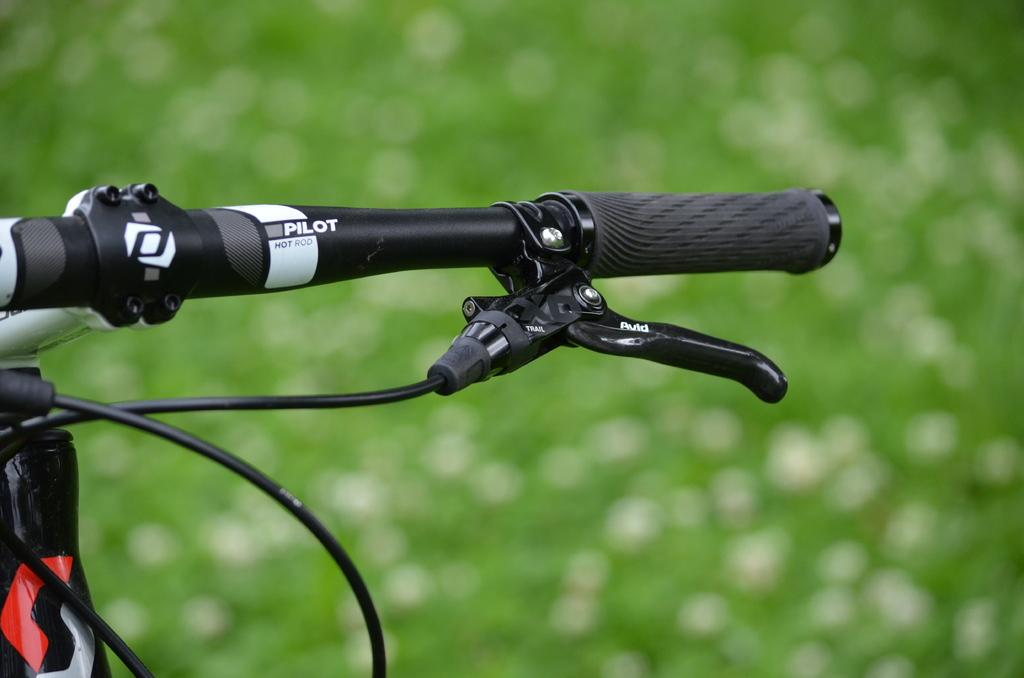What part of a cycle can be seen in the image? There is a cycle handle in the image. Can you describe the background of the image? The background of the image is blurred. What type of crack is visible in the image? There is no crack visible in the image. What action is being performed by the person in the image? There is no person visible in the image, so it is impossible to determine any actions being performed. 